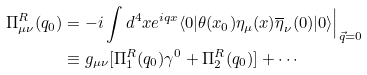<formula> <loc_0><loc_0><loc_500><loc_500>\Pi _ { \mu \nu } ^ { R } ( q _ { 0 } ) & = - i \int d ^ { 4 } x e ^ { i q x } \langle 0 | \theta ( x _ { 0 } ) \eta _ { \mu } ( x ) \overline { \eta } _ { \nu } ( 0 ) | 0 \rangle \Big | _ { \vec { q } = 0 } \\ & \equiv g _ { \mu \nu } [ \Pi _ { 1 } ^ { R } ( q _ { 0 } ) \gamma ^ { 0 } + \Pi _ { 2 } ^ { R } ( q _ { 0 } ) ] + \cdots</formula> 